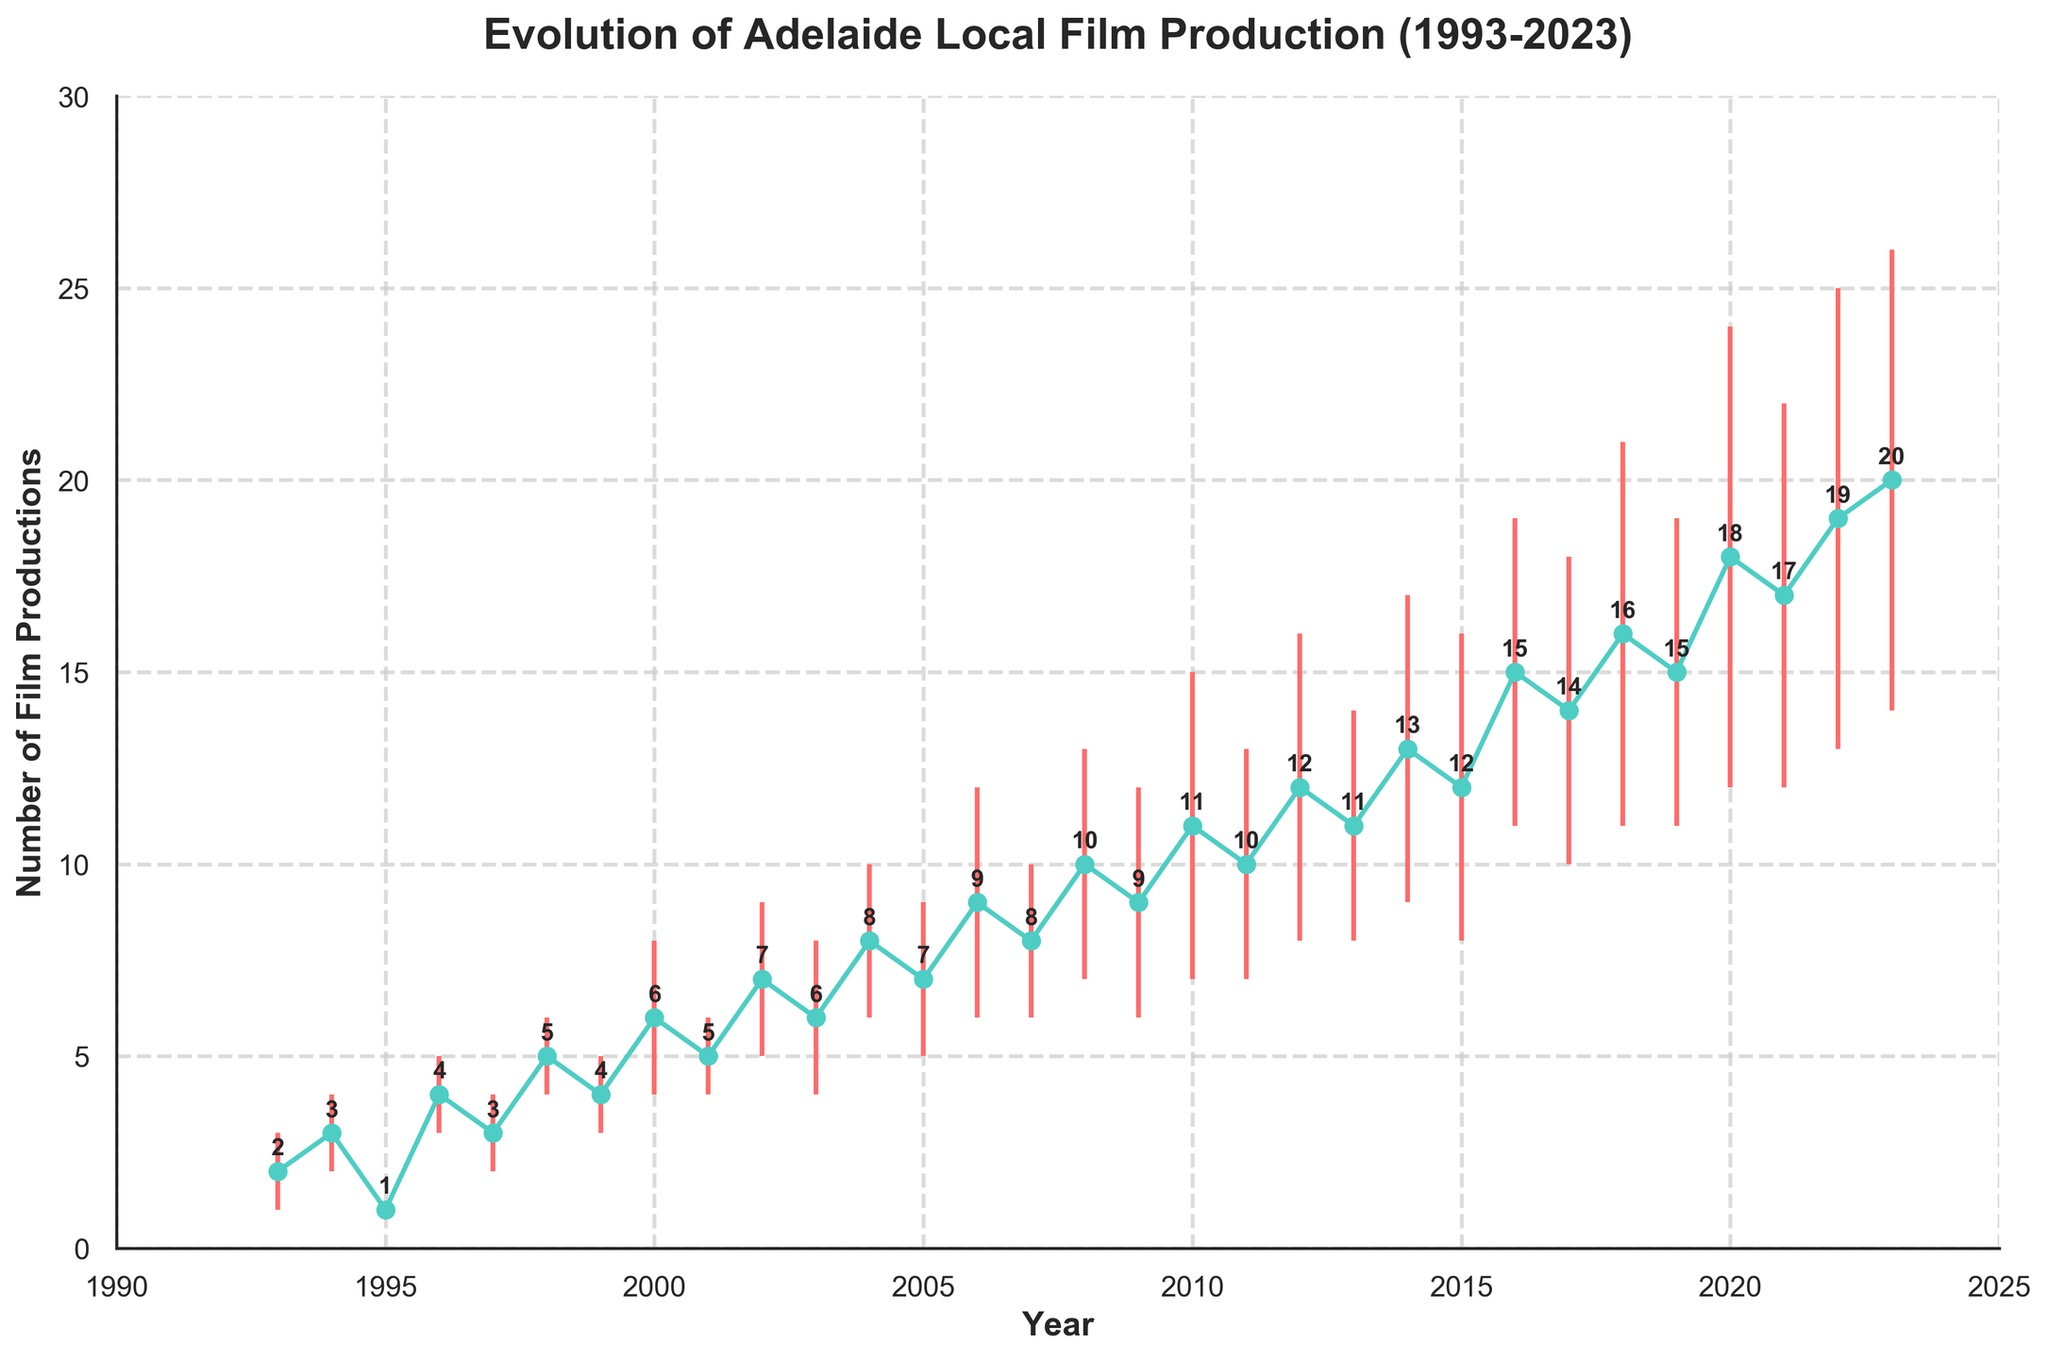What is the range of years depicted in the plot? The x-axis of the plot shows the years ranging from 1993 to 2023 as the horizontal axis is labeled with these specific years.
Answer: 1993 to 2023 How many film productions were recorded in the year 2000? Observing the data point at the year 2000 on the plot, it shows 6 film productions.
Answer: 6 Which year had the highest number of film productions and how many were there? By looking at the highest point on the line plot, the year 2023 had the highest number of film productions, which is 20.
Answer: 2023, 20 What is the trend in the number of film productions from 2018 to 2023? From examining the slope of the line between these years, there is an increasing trend with an upward trajectory in the number of productions each year.
Answer: Increasing trend How many years had film production counts that reached double digits? Identify each year where the plot's y-axis value is 10 or greater, which includes the years 2010 to 2023, thus making it 14 years.
Answer: 14 Was there any year where film productions decreased compared to the previous year? Comparing the data points year by year, the only decrease occurred from 2015 (12 productions) to 2016 (15 productions), indicating a reduction.
Answer: No What's the average number of film productions in the first decade (1993-2002)? Sum the number of film productions from 1993 to 2002: (2 + 3 + 1 + 4 + 3 + 5 + 4 + 6 + 5 + 7) = 40. There are 10 years, so the average is 40/10.
Answer: 4 What is the standard deviation range for the film productions in the year 2010? In 2010, the number of film productions is 11 with a standard deviation of 4, so the range is 11 ± 4, which is from 7 to 15.
Answer: 7 to 15 In which year did the error bars begin displaying a visible increase in variability, and what could this suggest? The error bars began to notably widen around 2006 (3) onwards, suggesting increasing variability or inconsistency in film production counts starting from that year.
Answer: 2006 How does the standard deviation in 2023 compare to that in 2010? The standard deviation in 2023 is 6 compared to 2010 which is 4, indicating a higher variability in the number of film productions in 2023.
Answer: Higher in 2023 